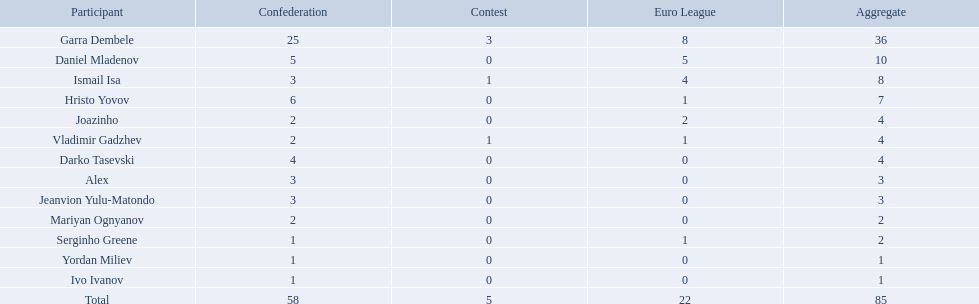What players did not score in all 3 competitions? Daniel Mladenov, Hristo Yovov, Joazinho, Darko Tasevski, Alex, Jeanvion Yulu-Matondo, Mariyan Ognyanov, Serginho Greene, Yordan Miliev, Ivo Ivanov. Which of those did not have total more then 5? Darko Tasevski, Alex, Jeanvion Yulu-Matondo, Mariyan Ognyanov, Serginho Greene, Yordan Miliev, Ivo Ivanov. Which ones scored more then 1 total? Darko Tasevski, Alex, Jeanvion Yulu-Matondo, Mariyan Ognyanov. Which of these player had the lease league points? Mariyan Ognyanov. 